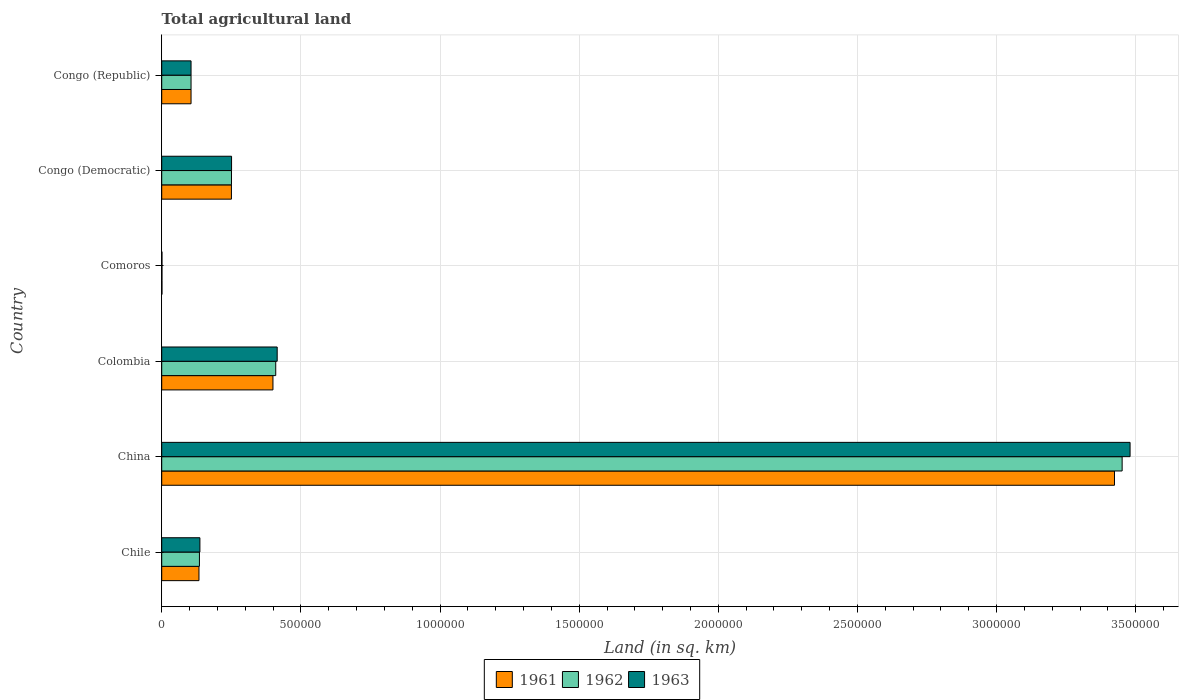How many different coloured bars are there?
Keep it short and to the point. 3. How many bars are there on the 4th tick from the top?
Make the answer very short. 3. How many bars are there on the 1st tick from the bottom?
Your response must be concise. 3. What is the label of the 2nd group of bars from the top?
Your answer should be very brief. Congo (Democratic). In how many cases, is the number of bars for a given country not equal to the number of legend labels?
Your answer should be compact. 0. What is the total agricultural land in 1961 in Congo (Republic)?
Offer a very short reply. 1.05e+05. Across all countries, what is the maximum total agricultural land in 1961?
Your answer should be compact. 3.42e+06. Across all countries, what is the minimum total agricultural land in 1961?
Offer a terse response. 950. In which country was the total agricultural land in 1961 minimum?
Make the answer very short. Comoros. What is the total total agricultural land in 1962 in the graph?
Offer a very short reply. 4.35e+06. What is the difference between the total agricultural land in 1961 in Chile and that in Congo (Republic)?
Make the answer very short. 2.85e+04. What is the difference between the total agricultural land in 1963 in Comoros and the total agricultural land in 1961 in Colombia?
Give a very brief answer. -3.99e+05. What is the average total agricultural land in 1963 per country?
Provide a succinct answer. 7.32e+05. What is the ratio of the total agricultural land in 1963 in China to that in Comoros?
Keep it short and to the point. 3662.63. Is the total agricultural land in 1961 in Colombia less than that in Congo (Republic)?
Your answer should be very brief. No. What is the difference between the highest and the second highest total agricultural land in 1961?
Provide a short and direct response. 3.02e+06. What is the difference between the highest and the lowest total agricultural land in 1961?
Offer a very short reply. 3.42e+06. How many bars are there?
Your answer should be very brief. 18. How many countries are there in the graph?
Keep it short and to the point. 6. What is the difference between two consecutive major ticks on the X-axis?
Provide a succinct answer. 5.00e+05. Where does the legend appear in the graph?
Ensure brevity in your answer.  Bottom center. What is the title of the graph?
Your response must be concise. Total agricultural land. What is the label or title of the X-axis?
Ensure brevity in your answer.  Land (in sq. km). What is the Land (in sq. km) in 1961 in Chile?
Give a very brief answer. 1.34e+05. What is the Land (in sq. km) of 1962 in Chile?
Your response must be concise. 1.36e+05. What is the Land (in sq. km) of 1963 in Chile?
Your answer should be compact. 1.37e+05. What is the Land (in sq. km) in 1961 in China?
Offer a very short reply. 3.42e+06. What is the Land (in sq. km) in 1962 in China?
Give a very brief answer. 3.45e+06. What is the Land (in sq. km) of 1963 in China?
Your answer should be compact. 3.48e+06. What is the Land (in sq. km) in 1961 in Colombia?
Give a very brief answer. 4.00e+05. What is the Land (in sq. km) in 1962 in Colombia?
Your answer should be very brief. 4.10e+05. What is the Land (in sq. km) of 1963 in Colombia?
Provide a succinct answer. 4.15e+05. What is the Land (in sq. km) of 1961 in Comoros?
Your response must be concise. 950. What is the Land (in sq. km) of 1962 in Comoros?
Offer a very short reply. 950. What is the Land (in sq. km) in 1963 in Comoros?
Your response must be concise. 950. What is the Land (in sq. km) of 1961 in Congo (Democratic)?
Provide a short and direct response. 2.50e+05. What is the Land (in sq. km) in 1962 in Congo (Democratic)?
Offer a very short reply. 2.51e+05. What is the Land (in sq. km) in 1963 in Congo (Democratic)?
Your answer should be compact. 2.51e+05. What is the Land (in sq. km) in 1961 in Congo (Republic)?
Give a very brief answer. 1.05e+05. What is the Land (in sq. km) of 1962 in Congo (Republic)?
Your answer should be compact. 1.05e+05. What is the Land (in sq. km) in 1963 in Congo (Republic)?
Your answer should be very brief. 1.05e+05. Across all countries, what is the maximum Land (in sq. km) in 1961?
Make the answer very short. 3.42e+06. Across all countries, what is the maximum Land (in sq. km) in 1962?
Offer a very short reply. 3.45e+06. Across all countries, what is the maximum Land (in sq. km) in 1963?
Make the answer very short. 3.48e+06. Across all countries, what is the minimum Land (in sq. km) in 1961?
Your response must be concise. 950. Across all countries, what is the minimum Land (in sq. km) of 1962?
Your answer should be very brief. 950. Across all countries, what is the minimum Land (in sq. km) of 1963?
Your answer should be compact. 950. What is the total Land (in sq. km) in 1961 in the graph?
Provide a succinct answer. 4.31e+06. What is the total Land (in sq. km) of 1962 in the graph?
Your answer should be compact. 4.35e+06. What is the total Land (in sq. km) in 1963 in the graph?
Your response must be concise. 4.39e+06. What is the difference between the Land (in sq. km) in 1961 in Chile and that in China?
Your response must be concise. -3.29e+06. What is the difference between the Land (in sq. km) of 1962 in Chile and that in China?
Give a very brief answer. -3.32e+06. What is the difference between the Land (in sq. km) in 1963 in Chile and that in China?
Your answer should be very brief. -3.34e+06. What is the difference between the Land (in sq. km) of 1961 in Chile and that in Colombia?
Provide a succinct answer. -2.66e+05. What is the difference between the Land (in sq. km) in 1962 in Chile and that in Colombia?
Make the answer very short. -2.74e+05. What is the difference between the Land (in sq. km) of 1963 in Chile and that in Colombia?
Offer a very short reply. -2.78e+05. What is the difference between the Land (in sq. km) in 1961 in Chile and that in Comoros?
Your answer should be very brief. 1.33e+05. What is the difference between the Land (in sq. km) of 1962 in Chile and that in Comoros?
Give a very brief answer. 1.35e+05. What is the difference between the Land (in sq. km) of 1963 in Chile and that in Comoros?
Provide a short and direct response. 1.36e+05. What is the difference between the Land (in sq. km) of 1961 in Chile and that in Congo (Democratic)?
Ensure brevity in your answer.  -1.17e+05. What is the difference between the Land (in sq. km) in 1962 in Chile and that in Congo (Democratic)?
Provide a short and direct response. -1.15e+05. What is the difference between the Land (in sq. km) in 1963 in Chile and that in Congo (Democratic)?
Your response must be concise. -1.14e+05. What is the difference between the Land (in sq. km) of 1961 in Chile and that in Congo (Republic)?
Keep it short and to the point. 2.85e+04. What is the difference between the Land (in sq. km) of 1962 in Chile and that in Congo (Republic)?
Provide a short and direct response. 3.02e+04. What is the difference between the Land (in sq. km) of 1963 in Chile and that in Congo (Republic)?
Provide a short and direct response. 3.18e+04. What is the difference between the Land (in sq. km) in 1961 in China and that in Colombia?
Keep it short and to the point. 3.02e+06. What is the difference between the Land (in sq. km) of 1962 in China and that in Colombia?
Your answer should be compact. 3.04e+06. What is the difference between the Land (in sq. km) in 1963 in China and that in Colombia?
Your response must be concise. 3.06e+06. What is the difference between the Land (in sq. km) in 1961 in China and that in Comoros?
Keep it short and to the point. 3.42e+06. What is the difference between the Land (in sq. km) of 1962 in China and that in Comoros?
Give a very brief answer. 3.45e+06. What is the difference between the Land (in sq. km) in 1963 in China and that in Comoros?
Offer a very short reply. 3.48e+06. What is the difference between the Land (in sq. km) of 1961 in China and that in Congo (Democratic)?
Your answer should be very brief. 3.17e+06. What is the difference between the Land (in sq. km) in 1962 in China and that in Congo (Democratic)?
Offer a very short reply. 3.20e+06. What is the difference between the Land (in sq. km) in 1963 in China and that in Congo (Democratic)?
Provide a short and direct response. 3.23e+06. What is the difference between the Land (in sq. km) of 1961 in China and that in Congo (Republic)?
Your answer should be compact. 3.32e+06. What is the difference between the Land (in sq. km) in 1962 in China and that in Congo (Republic)?
Your response must be concise. 3.35e+06. What is the difference between the Land (in sq. km) of 1963 in China and that in Congo (Republic)?
Provide a succinct answer. 3.37e+06. What is the difference between the Land (in sq. km) in 1961 in Colombia and that in Comoros?
Offer a terse response. 3.99e+05. What is the difference between the Land (in sq. km) in 1962 in Colombia and that in Comoros?
Provide a succinct answer. 4.09e+05. What is the difference between the Land (in sq. km) of 1963 in Colombia and that in Comoros?
Give a very brief answer. 4.14e+05. What is the difference between the Land (in sq. km) in 1961 in Colombia and that in Congo (Democratic)?
Offer a terse response. 1.49e+05. What is the difference between the Land (in sq. km) of 1962 in Colombia and that in Congo (Democratic)?
Offer a very short reply. 1.59e+05. What is the difference between the Land (in sq. km) in 1963 in Colombia and that in Congo (Democratic)?
Your answer should be compact. 1.64e+05. What is the difference between the Land (in sq. km) in 1961 in Colombia and that in Congo (Republic)?
Give a very brief answer. 2.94e+05. What is the difference between the Land (in sq. km) in 1962 in Colombia and that in Congo (Republic)?
Your answer should be very brief. 3.04e+05. What is the difference between the Land (in sq. km) in 1963 in Colombia and that in Congo (Republic)?
Provide a succinct answer. 3.10e+05. What is the difference between the Land (in sq. km) of 1961 in Comoros and that in Congo (Democratic)?
Provide a short and direct response. -2.50e+05. What is the difference between the Land (in sq. km) in 1962 in Comoros and that in Congo (Democratic)?
Give a very brief answer. -2.50e+05. What is the difference between the Land (in sq. km) in 1963 in Comoros and that in Congo (Democratic)?
Provide a short and direct response. -2.50e+05. What is the difference between the Land (in sq. km) in 1961 in Comoros and that in Congo (Republic)?
Ensure brevity in your answer.  -1.04e+05. What is the difference between the Land (in sq. km) of 1962 in Comoros and that in Congo (Republic)?
Your answer should be compact. -1.04e+05. What is the difference between the Land (in sq. km) of 1963 in Comoros and that in Congo (Republic)?
Provide a short and direct response. -1.04e+05. What is the difference between the Land (in sq. km) of 1961 in Congo (Democratic) and that in Congo (Republic)?
Keep it short and to the point. 1.45e+05. What is the difference between the Land (in sq. km) of 1962 in Congo (Democratic) and that in Congo (Republic)?
Your answer should be very brief. 1.45e+05. What is the difference between the Land (in sq. km) of 1963 in Congo (Democratic) and that in Congo (Republic)?
Ensure brevity in your answer.  1.46e+05. What is the difference between the Land (in sq. km) in 1961 in Chile and the Land (in sq. km) in 1962 in China?
Provide a succinct answer. -3.32e+06. What is the difference between the Land (in sq. km) in 1961 in Chile and the Land (in sq. km) in 1963 in China?
Ensure brevity in your answer.  -3.35e+06. What is the difference between the Land (in sq. km) in 1962 in Chile and the Land (in sq. km) in 1963 in China?
Your answer should be compact. -3.34e+06. What is the difference between the Land (in sq. km) in 1961 in Chile and the Land (in sq. km) in 1962 in Colombia?
Give a very brief answer. -2.76e+05. What is the difference between the Land (in sq. km) of 1961 in Chile and the Land (in sq. km) of 1963 in Colombia?
Offer a terse response. -2.81e+05. What is the difference between the Land (in sq. km) in 1962 in Chile and the Land (in sq. km) in 1963 in Colombia?
Ensure brevity in your answer.  -2.79e+05. What is the difference between the Land (in sq. km) in 1961 in Chile and the Land (in sq. km) in 1962 in Comoros?
Give a very brief answer. 1.33e+05. What is the difference between the Land (in sq. km) of 1961 in Chile and the Land (in sq. km) of 1963 in Comoros?
Provide a succinct answer. 1.33e+05. What is the difference between the Land (in sq. km) of 1962 in Chile and the Land (in sq. km) of 1963 in Comoros?
Provide a short and direct response. 1.35e+05. What is the difference between the Land (in sq. km) in 1961 in Chile and the Land (in sq. km) in 1962 in Congo (Democratic)?
Give a very brief answer. -1.17e+05. What is the difference between the Land (in sq. km) of 1961 in Chile and the Land (in sq. km) of 1963 in Congo (Democratic)?
Keep it short and to the point. -1.17e+05. What is the difference between the Land (in sq. km) of 1962 in Chile and the Land (in sq. km) of 1963 in Congo (Democratic)?
Your answer should be very brief. -1.15e+05. What is the difference between the Land (in sq. km) in 1961 in Chile and the Land (in sq. km) in 1962 in Congo (Republic)?
Offer a terse response. 2.85e+04. What is the difference between the Land (in sq. km) of 1961 in Chile and the Land (in sq. km) of 1963 in Congo (Republic)?
Offer a terse response. 2.84e+04. What is the difference between the Land (in sq. km) in 1962 in Chile and the Land (in sq. km) in 1963 in Congo (Republic)?
Offer a very short reply. 3.01e+04. What is the difference between the Land (in sq. km) in 1961 in China and the Land (in sq. km) in 1962 in Colombia?
Your answer should be very brief. 3.01e+06. What is the difference between the Land (in sq. km) of 1961 in China and the Land (in sq. km) of 1963 in Colombia?
Your answer should be compact. 3.01e+06. What is the difference between the Land (in sq. km) in 1962 in China and the Land (in sq. km) in 1963 in Colombia?
Ensure brevity in your answer.  3.04e+06. What is the difference between the Land (in sq. km) in 1961 in China and the Land (in sq. km) in 1962 in Comoros?
Your answer should be compact. 3.42e+06. What is the difference between the Land (in sq. km) of 1961 in China and the Land (in sq. km) of 1963 in Comoros?
Give a very brief answer. 3.42e+06. What is the difference between the Land (in sq. km) of 1962 in China and the Land (in sq. km) of 1963 in Comoros?
Provide a succinct answer. 3.45e+06. What is the difference between the Land (in sq. km) in 1961 in China and the Land (in sq. km) in 1962 in Congo (Democratic)?
Give a very brief answer. 3.17e+06. What is the difference between the Land (in sq. km) in 1961 in China and the Land (in sq. km) in 1963 in Congo (Democratic)?
Keep it short and to the point. 3.17e+06. What is the difference between the Land (in sq. km) in 1962 in China and the Land (in sq. km) in 1963 in Congo (Democratic)?
Give a very brief answer. 3.20e+06. What is the difference between the Land (in sq. km) in 1961 in China and the Land (in sq. km) in 1962 in Congo (Republic)?
Make the answer very short. 3.32e+06. What is the difference between the Land (in sq. km) in 1961 in China and the Land (in sq. km) in 1963 in Congo (Republic)?
Your response must be concise. 3.32e+06. What is the difference between the Land (in sq. km) of 1962 in China and the Land (in sq. km) of 1963 in Congo (Republic)?
Give a very brief answer. 3.35e+06. What is the difference between the Land (in sq. km) of 1961 in Colombia and the Land (in sq. km) of 1962 in Comoros?
Give a very brief answer. 3.99e+05. What is the difference between the Land (in sq. km) in 1961 in Colombia and the Land (in sq. km) in 1963 in Comoros?
Provide a succinct answer. 3.99e+05. What is the difference between the Land (in sq. km) of 1962 in Colombia and the Land (in sq. km) of 1963 in Comoros?
Your answer should be very brief. 4.09e+05. What is the difference between the Land (in sq. km) in 1961 in Colombia and the Land (in sq. km) in 1962 in Congo (Democratic)?
Offer a very short reply. 1.49e+05. What is the difference between the Land (in sq. km) in 1961 in Colombia and the Land (in sq. km) in 1963 in Congo (Democratic)?
Your answer should be compact. 1.49e+05. What is the difference between the Land (in sq. km) in 1962 in Colombia and the Land (in sq. km) in 1963 in Congo (Democratic)?
Keep it short and to the point. 1.59e+05. What is the difference between the Land (in sq. km) in 1961 in Colombia and the Land (in sq. km) in 1962 in Congo (Republic)?
Give a very brief answer. 2.94e+05. What is the difference between the Land (in sq. km) in 1961 in Colombia and the Land (in sq. km) in 1963 in Congo (Republic)?
Provide a succinct answer. 2.94e+05. What is the difference between the Land (in sq. km) of 1962 in Colombia and the Land (in sq. km) of 1963 in Congo (Republic)?
Your answer should be compact. 3.04e+05. What is the difference between the Land (in sq. km) of 1961 in Comoros and the Land (in sq. km) of 1962 in Congo (Democratic)?
Your response must be concise. -2.50e+05. What is the difference between the Land (in sq. km) of 1961 in Comoros and the Land (in sq. km) of 1963 in Congo (Democratic)?
Offer a terse response. -2.50e+05. What is the difference between the Land (in sq. km) of 1962 in Comoros and the Land (in sq. km) of 1963 in Congo (Democratic)?
Offer a terse response. -2.50e+05. What is the difference between the Land (in sq. km) in 1961 in Comoros and the Land (in sq. km) in 1962 in Congo (Republic)?
Your answer should be compact. -1.04e+05. What is the difference between the Land (in sq. km) of 1961 in Comoros and the Land (in sq. km) of 1963 in Congo (Republic)?
Your answer should be very brief. -1.04e+05. What is the difference between the Land (in sq. km) in 1962 in Comoros and the Land (in sq. km) in 1963 in Congo (Republic)?
Offer a very short reply. -1.04e+05. What is the difference between the Land (in sq. km) of 1961 in Congo (Democratic) and the Land (in sq. km) of 1962 in Congo (Republic)?
Offer a very short reply. 1.45e+05. What is the difference between the Land (in sq. km) of 1961 in Congo (Democratic) and the Land (in sq. km) of 1963 in Congo (Republic)?
Give a very brief answer. 1.45e+05. What is the difference between the Land (in sq. km) in 1962 in Congo (Democratic) and the Land (in sq. km) in 1963 in Congo (Republic)?
Provide a succinct answer. 1.45e+05. What is the average Land (in sq. km) in 1961 per country?
Keep it short and to the point. 7.19e+05. What is the average Land (in sq. km) of 1962 per country?
Your answer should be very brief. 7.26e+05. What is the average Land (in sq. km) of 1963 per country?
Provide a short and direct response. 7.32e+05. What is the difference between the Land (in sq. km) in 1961 and Land (in sq. km) in 1962 in Chile?
Offer a very short reply. -1700. What is the difference between the Land (in sq. km) of 1961 and Land (in sq. km) of 1963 in Chile?
Ensure brevity in your answer.  -3400. What is the difference between the Land (in sq. km) in 1962 and Land (in sq. km) in 1963 in Chile?
Your answer should be very brief. -1700. What is the difference between the Land (in sq. km) of 1961 and Land (in sq. km) of 1962 in China?
Your answer should be very brief. -2.75e+04. What is the difference between the Land (in sq. km) in 1961 and Land (in sq. km) in 1963 in China?
Give a very brief answer. -5.60e+04. What is the difference between the Land (in sq. km) of 1962 and Land (in sq. km) of 1963 in China?
Make the answer very short. -2.85e+04. What is the difference between the Land (in sq. km) of 1961 and Land (in sq. km) of 1962 in Colombia?
Offer a very short reply. -1.00e+04. What is the difference between the Land (in sq. km) of 1961 and Land (in sq. km) of 1963 in Colombia?
Offer a very short reply. -1.52e+04. What is the difference between the Land (in sq. km) of 1962 and Land (in sq. km) of 1963 in Colombia?
Provide a succinct answer. -5210. What is the difference between the Land (in sq. km) in 1961 and Land (in sq. km) in 1962 in Comoros?
Your answer should be very brief. 0. What is the difference between the Land (in sq. km) of 1961 and Land (in sq. km) of 1962 in Congo (Democratic)?
Ensure brevity in your answer.  -200. What is the difference between the Land (in sq. km) in 1961 and Land (in sq. km) in 1963 in Congo (Democratic)?
Provide a short and direct response. -500. What is the difference between the Land (in sq. km) of 1962 and Land (in sq. km) of 1963 in Congo (Democratic)?
Your answer should be compact. -300. What is the difference between the Land (in sq. km) in 1961 and Land (in sq. km) in 1963 in Congo (Republic)?
Ensure brevity in your answer.  -20. What is the ratio of the Land (in sq. km) in 1961 in Chile to that in China?
Your answer should be very brief. 0.04. What is the ratio of the Land (in sq. km) of 1962 in Chile to that in China?
Offer a terse response. 0.04. What is the ratio of the Land (in sq. km) in 1963 in Chile to that in China?
Offer a very short reply. 0.04. What is the ratio of the Land (in sq. km) of 1961 in Chile to that in Colombia?
Your response must be concise. 0.33. What is the ratio of the Land (in sq. km) of 1962 in Chile to that in Colombia?
Your answer should be compact. 0.33. What is the ratio of the Land (in sq. km) of 1963 in Chile to that in Colombia?
Offer a very short reply. 0.33. What is the ratio of the Land (in sq. km) of 1961 in Chile to that in Comoros?
Offer a very short reply. 140.91. What is the ratio of the Land (in sq. km) of 1962 in Chile to that in Comoros?
Make the answer very short. 142.69. What is the ratio of the Land (in sq. km) of 1963 in Chile to that in Comoros?
Offer a terse response. 144.48. What is the ratio of the Land (in sq. km) in 1961 in Chile to that in Congo (Democratic)?
Make the answer very short. 0.53. What is the ratio of the Land (in sq. km) in 1962 in Chile to that in Congo (Democratic)?
Keep it short and to the point. 0.54. What is the ratio of the Land (in sq. km) in 1963 in Chile to that in Congo (Democratic)?
Your answer should be compact. 0.55. What is the ratio of the Land (in sq. km) of 1961 in Chile to that in Congo (Republic)?
Provide a succinct answer. 1.27. What is the ratio of the Land (in sq. km) of 1962 in Chile to that in Congo (Republic)?
Ensure brevity in your answer.  1.29. What is the ratio of the Land (in sq. km) in 1963 in Chile to that in Congo (Republic)?
Your response must be concise. 1.3. What is the ratio of the Land (in sq. km) in 1961 in China to that in Colombia?
Provide a short and direct response. 8.57. What is the ratio of the Land (in sq. km) in 1962 in China to that in Colombia?
Your answer should be compact. 8.42. What is the ratio of the Land (in sq. km) of 1963 in China to that in Colombia?
Give a very brief answer. 8.39. What is the ratio of the Land (in sq. km) of 1961 in China to that in Comoros?
Your answer should be very brief. 3603.68. What is the ratio of the Land (in sq. km) of 1962 in China to that in Comoros?
Keep it short and to the point. 3632.63. What is the ratio of the Land (in sq. km) in 1963 in China to that in Comoros?
Make the answer very short. 3662.63. What is the ratio of the Land (in sq. km) in 1961 in China to that in Congo (Democratic)?
Offer a very short reply. 13.67. What is the ratio of the Land (in sq. km) in 1962 in China to that in Congo (Democratic)?
Your answer should be very brief. 13.77. What is the ratio of the Land (in sq. km) of 1963 in China to that in Congo (Democratic)?
Keep it short and to the point. 13.86. What is the ratio of the Land (in sq. km) in 1961 in China to that in Congo (Republic)?
Your answer should be compact. 32.48. What is the ratio of the Land (in sq. km) in 1962 in China to that in Congo (Republic)?
Your answer should be compact. 32.74. What is the ratio of the Land (in sq. km) in 1963 in China to that in Congo (Republic)?
Give a very brief answer. 33.01. What is the ratio of the Land (in sq. km) in 1961 in Colombia to that in Comoros?
Make the answer very short. 420.74. What is the ratio of the Land (in sq. km) in 1962 in Colombia to that in Comoros?
Provide a succinct answer. 431.28. What is the ratio of the Land (in sq. km) of 1963 in Colombia to that in Comoros?
Give a very brief answer. 436.77. What is the ratio of the Land (in sq. km) of 1961 in Colombia to that in Congo (Democratic)?
Provide a short and direct response. 1.6. What is the ratio of the Land (in sq. km) in 1962 in Colombia to that in Congo (Democratic)?
Offer a very short reply. 1.63. What is the ratio of the Land (in sq. km) in 1963 in Colombia to that in Congo (Democratic)?
Make the answer very short. 1.65. What is the ratio of the Land (in sq. km) of 1961 in Colombia to that in Congo (Republic)?
Make the answer very short. 3.79. What is the ratio of the Land (in sq. km) of 1962 in Colombia to that in Congo (Republic)?
Your response must be concise. 3.89. What is the ratio of the Land (in sq. km) of 1963 in Colombia to that in Congo (Republic)?
Provide a succinct answer. 3.94. What is the ratio of the Land (in sq. km) of 1961 in Comoros to that in Congo (Democratic)?
Offer a very short reply. 0. What is the ratio of the Land (in sq. km) of 1962 in Comoros to that in Congo (Democratic)?
Offer a very short reply. 0. What is the ratio of the Land (in sq. km) in 1963 in Comoros to that in Congo (Democratic)?
Your answer should be very brief. 0. What is the ratio of the Land (in sq. km) of 1961 in Comoros to that in Congo (Republic)?
Your response must be concise. 0.01. What is the ratio of the Land (in sq. km) in 1962 in Comoros to that in Congo (Republic)?
Your answer should be very brief. 0.01. What is the ratio of the Land (in sq. km) of 1963 in Comoros to that in Congo (Republic)?
Your answer should be very brief. 0.01. What is the ratio of the Land (in sq. km) in 1961 in Congo (Democratic) to that in Congo (Republic)?
Keep it short and to the point. 2.38. What is the ratio of the Land (in sq. km) of 1962 in Congo (Democratic) to that in Congo (Republic)?
Give a very brief answer. 2.38. What is the ratio of the Land (in sq. km) of 1963 in Congo (Democratic) to that in Congo (Republic)?
Offer a very short reply. 2.38. What is the difference between the highest and the second highest Land (in sq. km) in 1961?
Your answer should be compact. 3.02e+06. What is the difference between the highest and the second highest Land (in sq. km) of 1962?
Make the answer very short. 3.04e+06. What is the difference between the highest and the second highest Land (in sq. km) in 1963?
Your answer should be very brief. 3.06e+06. What is the difference between the highest and the lowest Land (in sq. km) in 1961?
Offer a very short reply. 3.42e+06. What is the difference between the highest and the lowest Land (in sq. km) of 1962?
Your answer should be very brief. 3.45e+06. What is the difference between the highest and the lowest Land (in sq. km) in 1963?
Provide a succinct answer. 3.48e+06. 